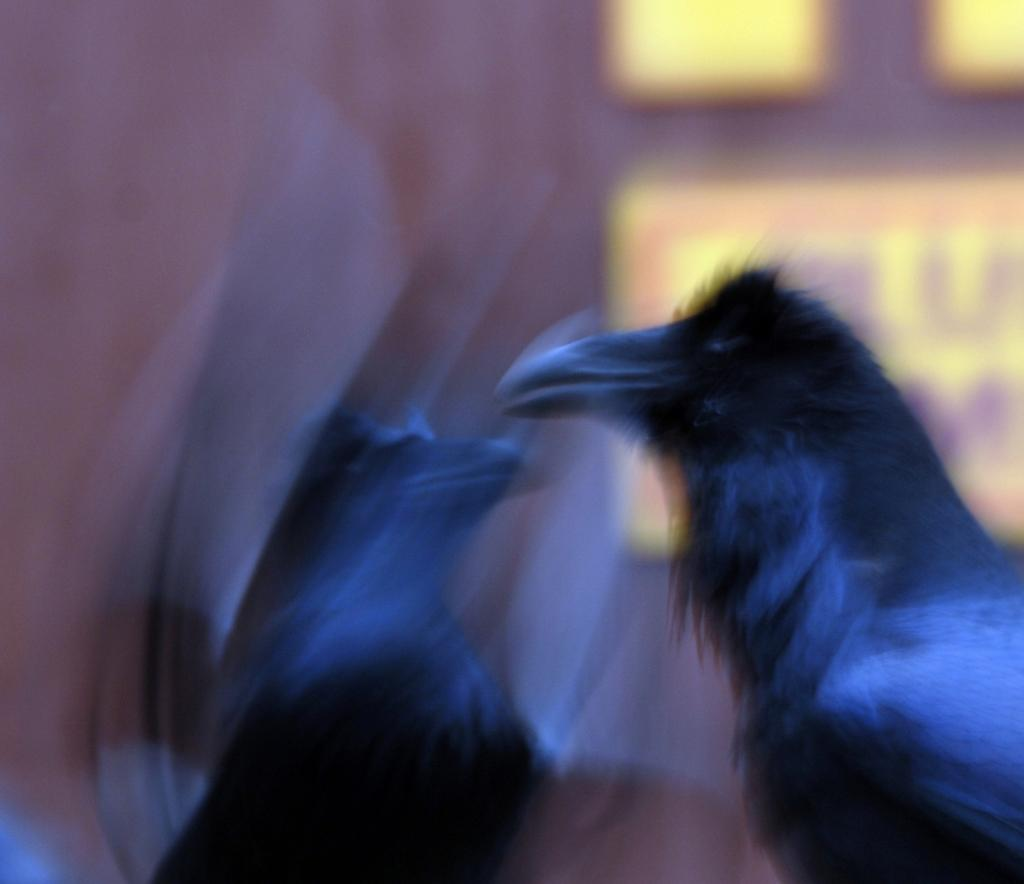How many birds are present in the image? There are two birds in the image. What type of milk is being poured into the plough by the plane in the image? There is no milk, plough, or plane present in the image. The image only features two birds. 